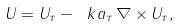Convert formula to latex. <formula><loc_0><loc_0><loc_500><loc_500>U = U _ { \tau } - \ k a _ { \tau } \, \nabla \times U _ { \tau } ,</formula> 